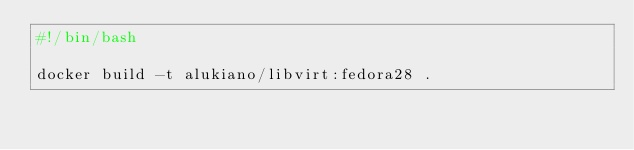<code> <loc_0><loc_0><loc_500><loc_500><_Bash_>#!/bin/bash

docker build -t alukiano/libvirt:fedora28 .
</code> 